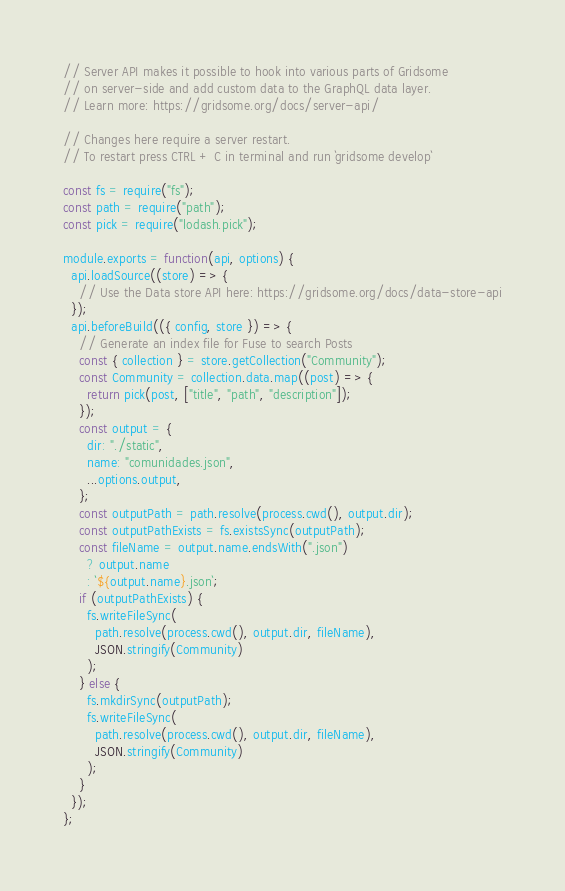<code> <loc_0><loc_0><loc_500><loc_500><_JavaScript_>// Server API makes it possible to hook into various parts of Gridsome
// on server-side and add custom data to the GraphQL data layer.
// Learn more: https://gridsome.org/docs/server-api/

// Changes here require a server restart.
// To restart press CTRL + C in terminal and run `gridsome develop`

const fs = require("fs");
const path = require("path");
const pick = require("lodash.pick");

module.exports = function(api, options) {
  api.loadSource((store) => {
    // Use the Data store API here: https://gridsome.org/docs/data-store-api
  });
  api.beforeBuild(({ config, store }) => {
    // Generate an index file for Fuse to search Posts
    const { collection } = store.getCollection("Community");
    const Community = collection.data.map((post) => {
      return pick(post, ["title", "path", "description"]);
    });
    const output = {
      dir: "./static",
      name: "comunidades.json",
      ...options.output,
    };
    const outputPath = path.resolve(process.cwd(), output.dir);
    const outputPathExists = fs.existsSync(outputPath);
    const fileName = output.name.endsWith(".json")
      ? output.name
      : `${output.name}.json`;
    if (outputPathExists) {
      fs.writeFileSync(
        path.resolve(process.cwd(), output.dir, fileName),
        JSON.stringify(Community)
      );
    } else {
      fs.mkdirSync(outputPath);
      fs.writeFileSync(
        path.resolve(process.cwd(), output.dir, fileName),
        JSON.stringify(Community)
      );
    }
  });
};
</code> 